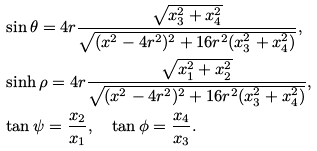Convert formula to latex. <formula><loc_0><loc_0><loc_500><loc_500>& \sin \theta = 4 r \frac { \sqrt { x _ { 3 } ^ { 2 } + x _ { 4 } ^ { 2 } } } { \sqrt { ( x ^ { 2 } - 4 r ^ { 2 } ) ^ { 2 } + 1 6 r ^ { 2 } ( x _ { 3 } ^ { 2 } + x _ { 4 } ^ { 2 } ) } } , \\ & \sinh \rho = 4 r \frac { \sqrt { x _ { 1 } ^ { 2 } + x _ { 2 } ^ { 2 } } } { \sqrt { ( x ^ { 2 } - 4 r ^ { 2 } ) ^ { 2 } + 1 6 r ^ { 2 } ( x _ { 3 } ^ { 2 } + x _ { 4 } ^ { 2 } ) } } , \\ & \tan \psi = \frac { x _ { 2 } } { x _ { 1 } } , \quad \tan \phi = \frac { x _ { 4 } } { x _ { 3 } } .</formula> 